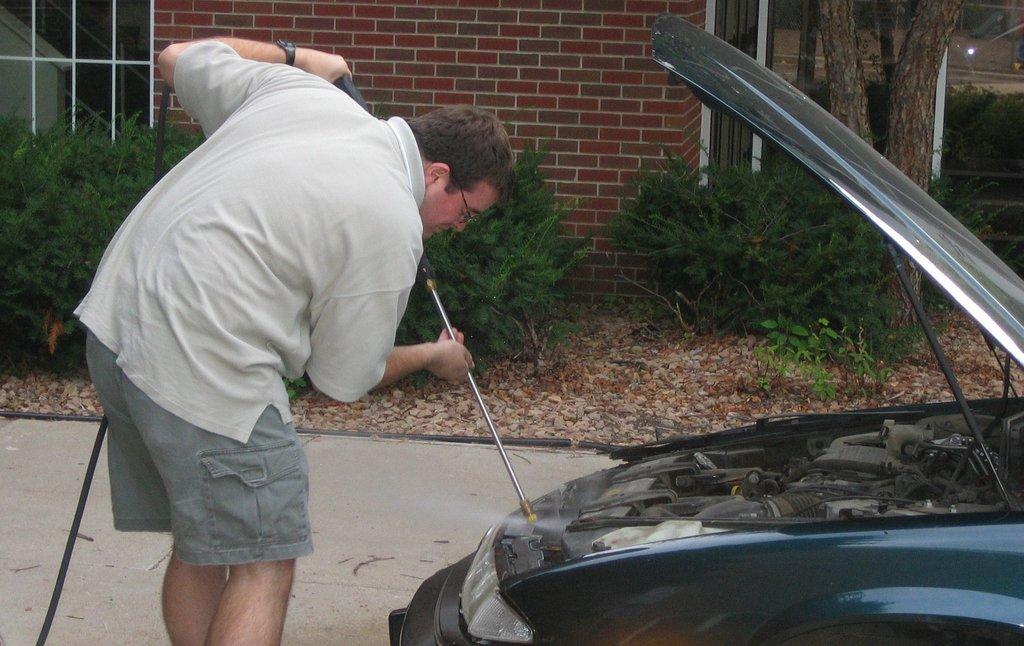Please provide a concise description of this image. On the left side, there is a person in a t-shirt, holding a tube and bending slightly. On the right side, there is a vehicle on the road. In the background, there are plants, trees and stones on the ground and there is a building having brick wall. 